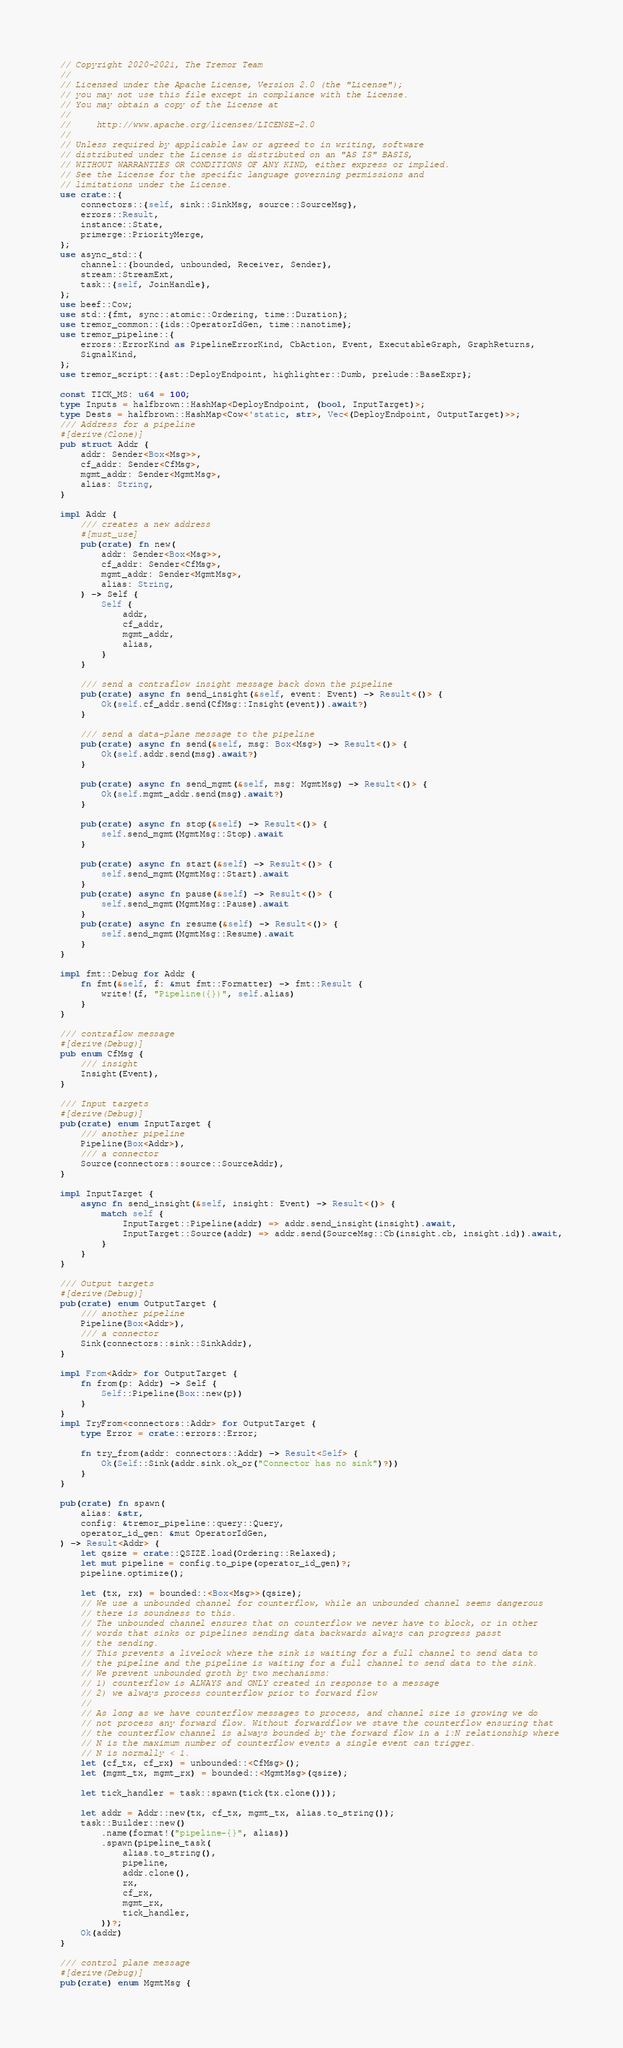Convert code to text. <code><loc_0><loc_0><loc_500><loc_500><_Rust_>// Copyright 2020-2021, The Tremor Team
//
// Licensed under the Apache License, Version 2.0 (the "License");
// you may not use this file except in compliance with the License.
// You may obtain a copy of the License at
//
//     http://www.apache.org/licenses/LICENSE-2.0
//
// Unless required by applicable law or agreed to in writing, software
// distributed under the License is distributed on an "AS IS" BASIS,
// WITHOUT WARRANTIES OR CONDITIONS OF ANY KIND, either express or implied.
// See the License for the specific language governing permissions and
// limitations under the License.
use crate::{
    connectors::{self, sink::SinkMsg, source::SourceMsg},
    errors::Result,
    instance::State,
    primerge::PriorityMerge,
};
use async_std::{
    channel::{bounded, unbounded, Receiver, Sender},
    stream::StreamExt,
    task::{self, JoinHandle},
};
use beef::Cow;
use std::{fmt, sync::atomic::Ordering, time::Duration};
use tremor_common::{ids::OperatorIdGen, time::nanotime};
use tremor_pipeline::{
    errors::ErrorKind as PipelineErrorKind, CbAction, Event, ExecutableGraph, GraphReturns,
    SignalKind,
};
use tremor_script::{ast::DeployEndpoint, highlighter::Dumb, prelude::BaseExpr};

const TICK_MS: u64 = 100;
type Inputs = halfbrown::HashMap<DeployEndpoint, (bool, InputTarget)>;
type Dests = halfbrown::HashMap<Cow<'static, str>, Vec<(DeployEndpoint, OutputTarget)>>;
/// Address for a pipeline
#[derive(Clone)]
pub struct Addr {
    addr: Sender<Box<Msg>>,
    cf_addr: Sender<CfMsg>,
    mgmt_addr: Sender<MgmtMsg>,
    alias: String,
}

impl Addr {
    /// creates a new address
    #[must_use]
    pub(crate) fn new(
        addr: Sender<Box<Msg>>,
        cf_addr: Sender<CfMsg>,
        mgmt_addr: Sender<MgmtMsg>,
        alias: String,
    ) -> Self {
        Self {
            addr,
            cf_addr,
            mgmt_addr,
            alias,
        }
    }

    /// send a contraflow insight message back down the pipeline
    pub(crate) async fn send_insight(&self, event: Event) -> Result<()> {
        Ok(self.cf_addr.send(CfMsg::Insight(event)).await?)
    }

    /// send a data-plane message to the pipeline
    pub(crate) async fn send(&self, msg: Box<Msg>) -> Result<()> {
        Ok(self.addr.send(msg).await?)
    }

    pub(crate) async fn send_mgmt(&self, msg: MgmtMsg) -> Result<()> {
        Ok(self.mgmt_addr.send(msg).await?)
    }

    pub(crate) async fn stop(&self) -> Result<()> {
        self.send_mgmt(MgmtMsg::Stop).await
    }

    pub(crate) async fn start(&self) -> Result<()> {
        self.send_mgmt(MgmtMsg::Start).await
    }
    pub(crate) async fn pause(&self) -> Result<()> {
        self.send_mgmt(MgmtMsg::Pause).await
    }
    pub(crate) async fn resume(&self) -> Result<()> {
        self.send_mgmt(MgmtMsg::Resume).await
    }
}

impl fmt::Debug for Addr {
    fn fmt(&self, f: &mut fmt::Formatter) -> fmt::Result {
        write!(f, "Pipeline({})", self.alias)
    }
}

/// contraflow message
#[derive(Debug)]
pub enum CfMsg {
    /// insight
    Insight(Event),
}

/// Input targets
#[derive(Debug)]
pub(crate) enum InputTarget {
    /// another pipeline
    Pipeline(Box<Addr>),
    /// a connector
    Source(connectors::source::SourceAddr),
}

impl InputTarget {
    async fn send_insight(&self, insight: Event) -> Result<()> {
        match self {
            InputTarget::Pipeline(addr) => addr.send_insight(insight).await,
            InputTarget::Source(addr) => addr.send(SourceMsg::Cb(insight.cb, insight.id)).await,
        }
    }
}

/// Output targets
#[derive(Debug)]
pub(crate) enum OutputTarget {
    /// another pipeline
    Pipeline(Box<Addr>),
    /// a connector
    Sink(connectors::sink::SinkAddr),
}

impl From<Addr> for OutputTarget {
    fn from(p: Addr) -> Self {
        Self::Pipeline(Box::new(p))
    }
}
impl TryFrom<connectors::Addr> for OutputTarget {
    type Error = crate::errors::Error;

    fn try_from(addr: connectors::Addr) -> Result<Self> {
        Ok(Self::Sink(addr.sink.ok_or("Connector has no sink")?))
    }
}

pub(crate) fn spawn(
    alias: &str,
    config: &tremor_pipeline::query::Query,
    operator_id_gen: &mut OperatorIdGen,
) -> Result<Addr> {
    let qsize = crate::QSIZE.load(Ordering::Relaxed);
    let mut pipeline = config.to_pipe(operator_id_gen)?;
    pipeline.optimize();

    let (tx, rx) = bounded::<Box<Msg>>(qsize);
    // We use a unbounded channel for counterflow, while an unbounded channel seems dangerous
    // there is soundness to this.
    // The unbounded channel ensures that on counterflow we never have to block, or in other
    // words that sinks or pipelines sending data backwards always can progress passt
    // the sending.
    // This prevents a livelock where the sink is waiting for a full channel to send data to
    // the pipeline and the pipeline is waiting for a full channel to send data to the sink.
    // We prevent unbounded groth by two mechanisms:
    // 1) counterflow is ALWAYS and ONLY created in response to a message
    // 2) we always process counterflow prior to forward flow
    //
    // As long as we have counterflow messages to process, and channel size is growing we do
    // not process any forward flow. Without forwardflow we stave the counterflow ensuring that
    // the counterflow channel is always bounded by the forward flow in a 1:N relationship where
    // N is the maximum number of counterflow events a single event can trigger.
    // N is normally < 1.
    let (cf_tx, cf_rx) = unbounded::<CfMsg>();
    let (mgmt_tx, mgmt_rx) = bounded::<MgmtMsg>(qsize);

    let tick_handler = task::spawn(tick(tx.clone()));

    let addr = Addr::new(tx, cf_tx, mgmt_tx, alias.to_string());
    task::Builder::new()
        .name(format!("pipeline-{}", alias))
        .spawn(pipeline_task(
            alias.to_string(),
            pipeline,
            addr.clone(),
            rx,
            cf_rx,
            mgmt_rx,
            tick_handler,
        ))?;
    Ok(addr)
}

/// control plane message
#[derive(Debug)]
pub(crate) enum MgmtMsg {</code> 